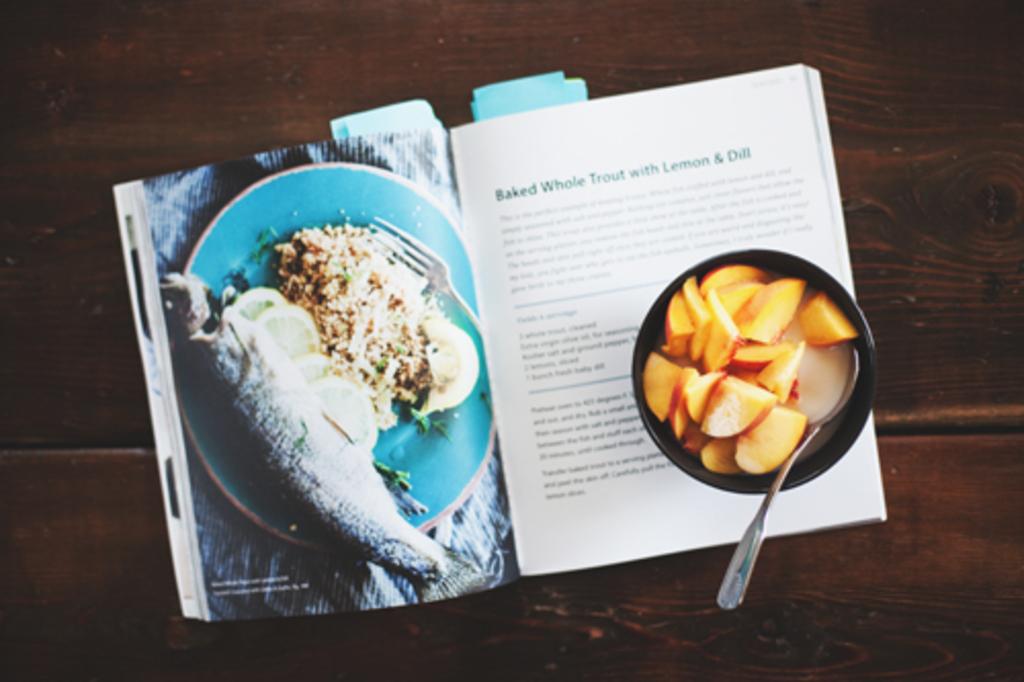What is the book about?
Keep it short and to the point. Cooking. What is the recipe for?
Your response must be concise. Baked whole trout with lemon & dill. 